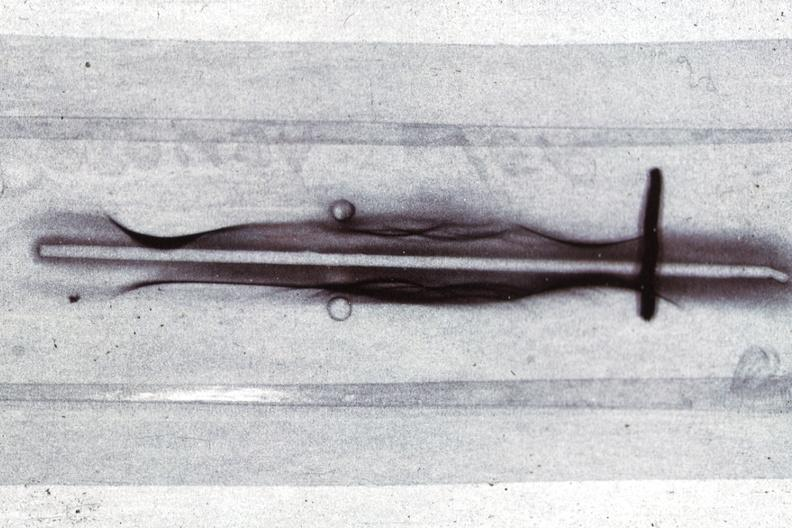does this image show immunoelectrophoresis showing monoclonal band which is an igg case of multiple myeloma?
Answer the question using a single word or phrase. Yes 